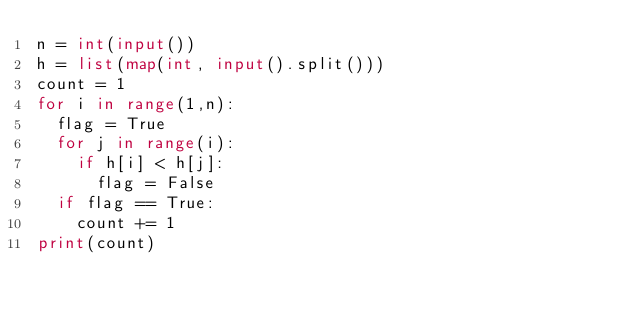Convert code to text. <code><loc_0><loc_0><loc_500><loc_500><_Python_>n = int(input())
h = list(map(int, input().split()))
count = 1
for i in range(1,n):
  flag = True
  for j in range(i):
    if h[i] < h[j]:
      flag = False
  if flag == True:
    count += 1
print(count)</code> 